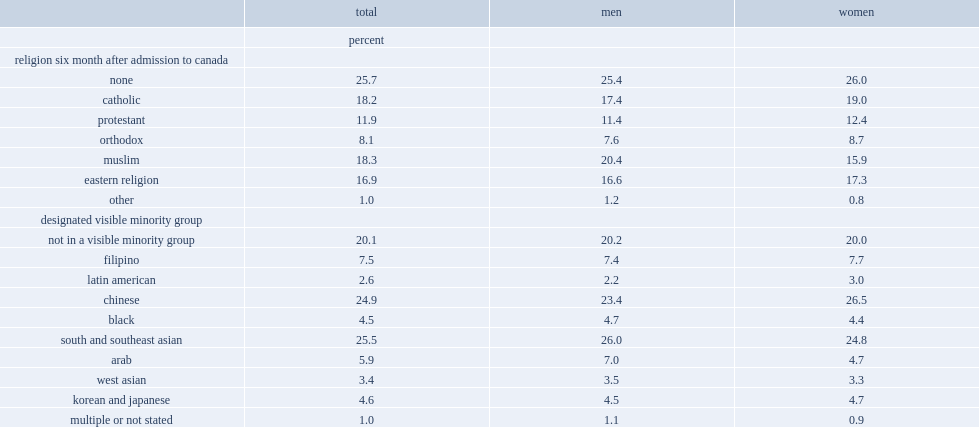What is the percentage pf immigrants who were muslim? 18.3. What is the percentage pf immigrants who were catholic? 18.2. What is the percentage pf immmigrants who were eastern religion (including hindu, sikh and buddhist)? 16.9. What is the percentage pf immigrants who were protestant? 11.9. With regard to visible minority status, what is the percentage of the immigrants admitted in 2001 were chinese? 24.9. With regard to visible minority status, what is the percentage of the immigrants admitted in 2001 were south asian or southeast asian? 25.5. With regard to visible minority status, what is the percentage of the immigrants admitted in 2001 were not part of a visible minority group? 20.1. 